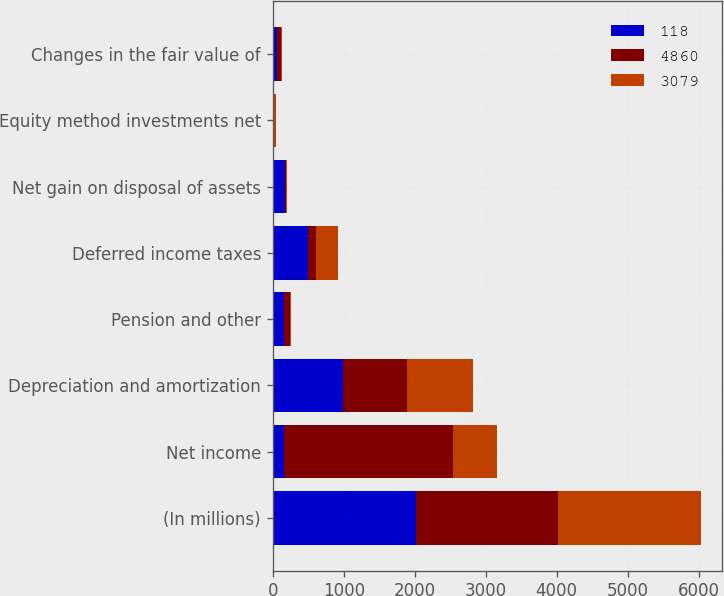Convert chart. <chart><loc_0><loc_0><loc_500><loc_500><stacked_bar_chart><ecel><fcel>(In millions)<fcel>Net income<fcel>Depreciation and amortization<fcel>Pension and other<fcel>Deferred income taxes<fcel>Net gain on disposal of assets<fcel>Equity method investments net<fcel>Changes in the fair value of<nl><fcel>118<fcel>2012<fcel>153<fcel>995<fcel>153<fcel>492<fcel>177<fcel>11<fcel>59<nl><fcel>4860<fcel>2011<fcel>2389<fcel>891<fcel>90<fcel>123<fcel>12<fcel>2<fcel>57<nl><fcel>3079<fcel>2010<fcel>623<fcel>941<fcel>13<fcel>308<fcel>11<fcel>34<fcel>16<nl></chart> 